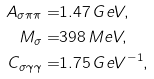Convert formula to latex. <formula><loc_0><loc_0><loc_500><loc_500>A _ { \sigma \pi \pi } = & 1 . 4 7 \, G e V , \\ M _ { \sigma } = & 3 9 8 \, M e V , \\ C _ { \sigma \gamma \gamma } = & 1 . 7 5 \, G e V ^ { - 1 } ,</formula> 